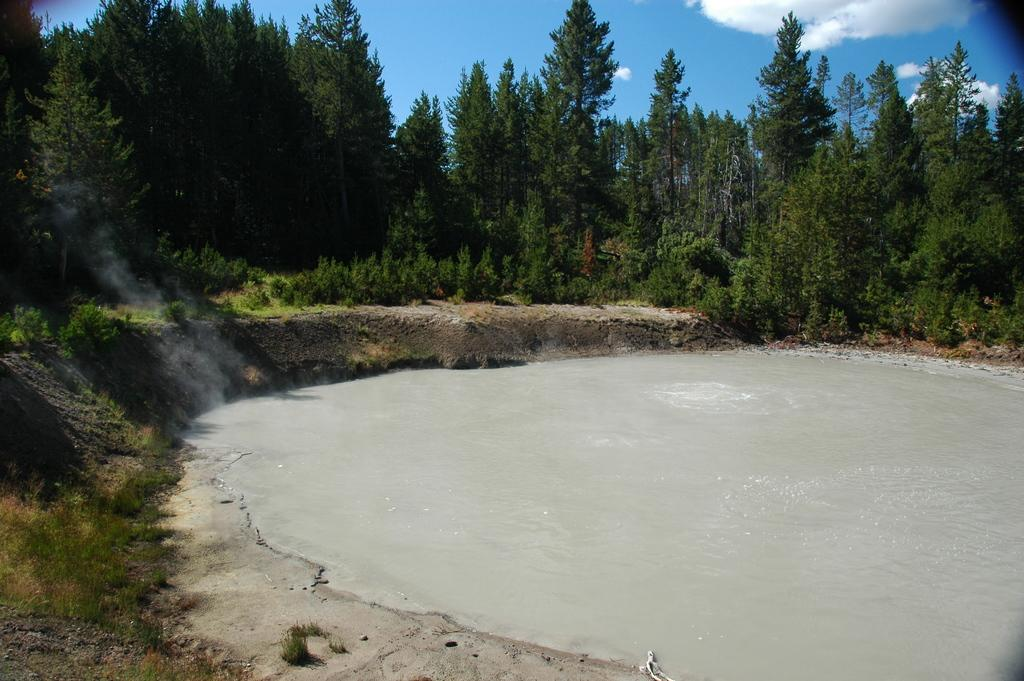What is located in the front of the image? There is a small water pond in the front of the image. What can be seen behind the water pond? There are huge trees behind the water pond. What is visible at the top of the image? The sky is visible at the top of the image. What can be observed in the sky? Clouds are present in the sky. What type of underwear is hanging on the tree in the image? There is no underwear present in the image; it features a small water pond, huge trees, and clouds in the sky. How many chins does the tree in the image have? Trees do not have chins, so this question cannot be answered. 